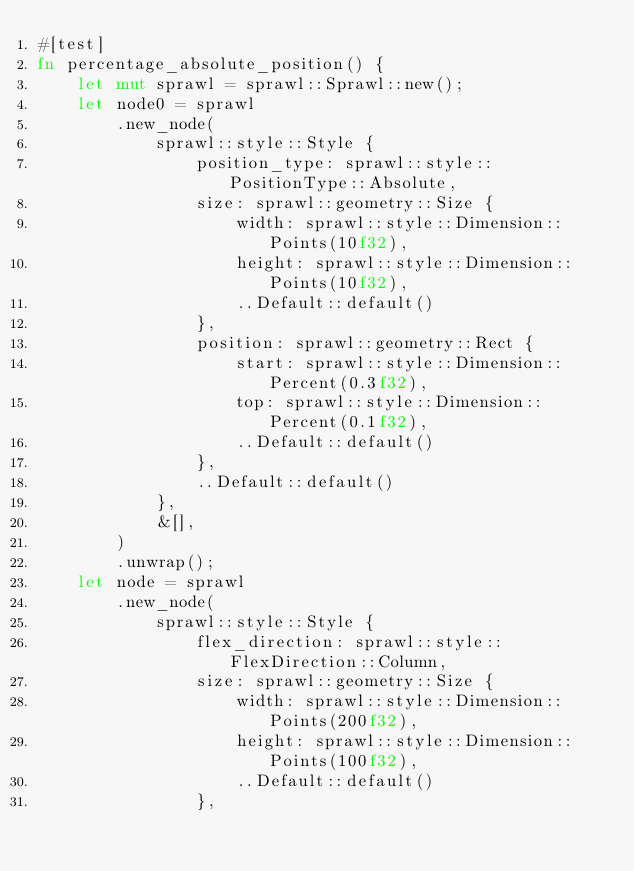<code> <loc_0><loc_0><loc_500><loc_500><_Rust_>#[test]
fn percentage_absolute_position() {
    let mut sprawl = sprawl::Sprawl::new();
    let node0 = sprawl
        .new_node(
            sprawl::style::Style {
                position_type: sprawl::style::PositionType::Absolute,
                size: sprawl::geometry::Size {
                    width: sprawl::style::Dimension::Points(10f32),
                    height: sprawl::style::Dimension::Points(10f32),
                    ..Default::default()
                },
                position: sprawl::geometry::Rect {
                    start: sprawl::style::Dimension::Percent(0.3f32),
                    top: sprawl::style::Dimension::Percent(0.1f32),
                    ..Default::default()
                },
                ..Default::default()
            },
            &[],
        )
        .unwrap();
    let node = sprawl
        .new_node(
            sprawl::style::Style {
                flex_direction: sprawl::style::FlexDirection::Column,
                size: sprawl::geometry::Size {
                    width: sprawl::style::Dimension::Points(200f32),
                    height: sprawl::style::Dimension::Points(100f32),
                    ..Default::default()
                },</code> 